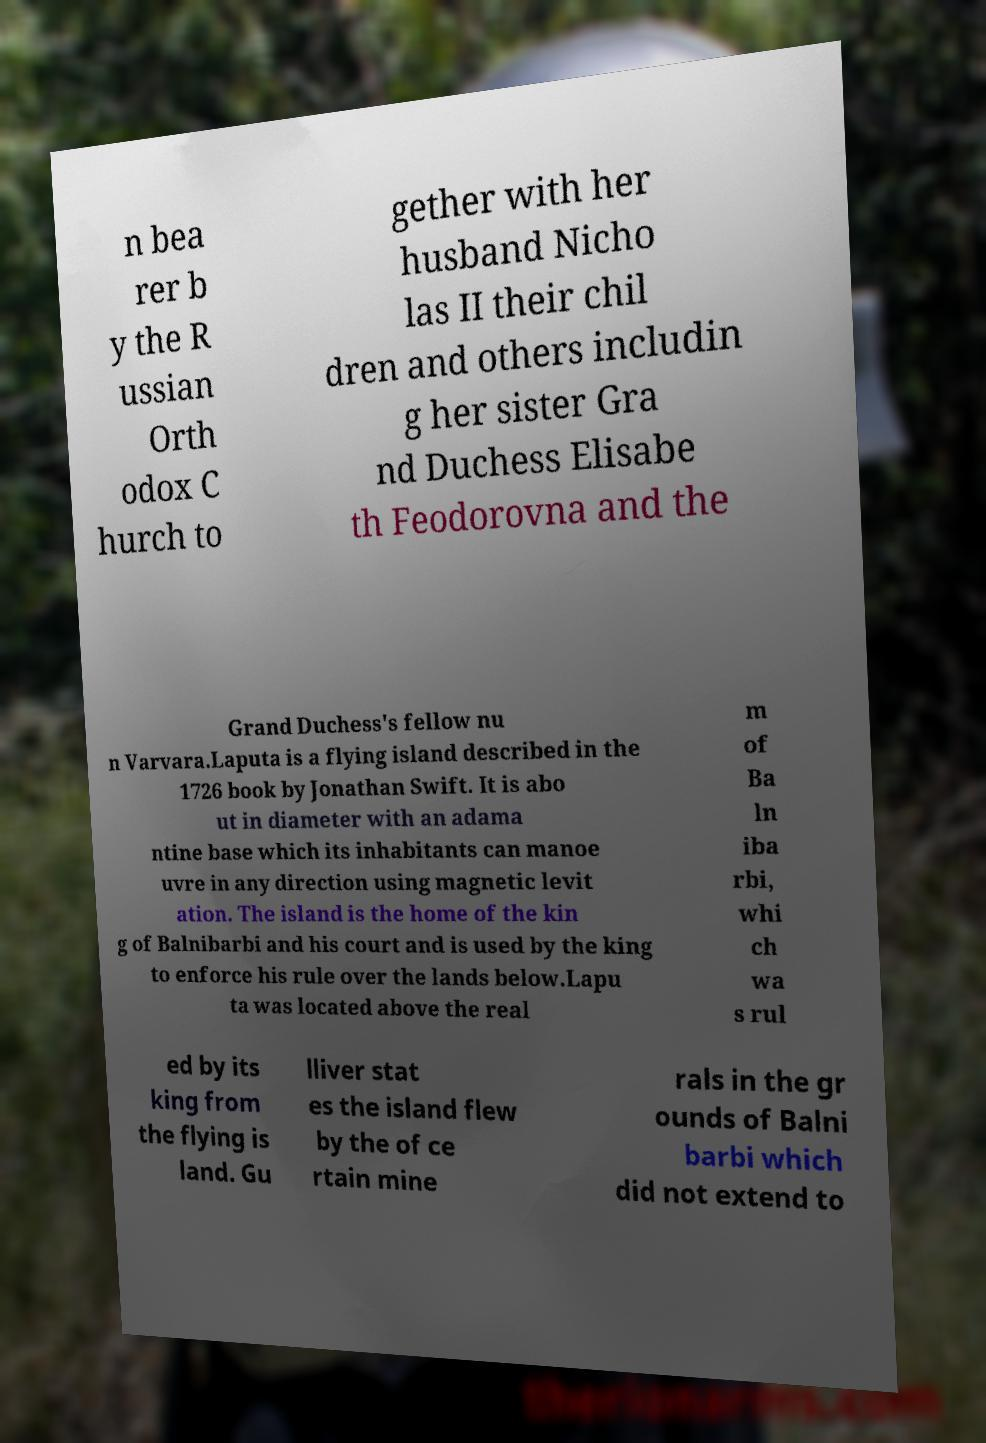I need the written content from this picture converted into text. Can you do that? n bea rer b y the R ussian Orth odox C hurch to gether with her husband Nicho las II their chil dren and others includin g her sister Gra nd Duchess Elisabe th Feodorovna and the Grand Duchess's fellow nu n Varvara.Laputa is a flying island described in the 1726 book by Jonathan Swift. It is abo ut in diameter with an adama ntine base which its inhabitants can manoe uvre in any direction using magnetic levit ation. The island is the home of the kin g of Balnibarbi and his court and is used by the king to enforce his rule over the lands below.Lapu ta was located above the real m of Ba ln iba rbi, whi ch wa s rul ed by its king from the flying is land. Gu lliver stat es the island flew by the of ce rtain mine rals in the gr ounds of Balni barbi which did not extend to 